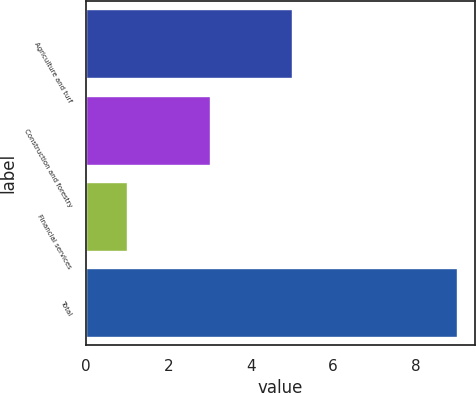<chart> <loc_0><loc_0><loc_500><loc_500><bar_chart><fcel>Agriculture and turf<fcel>Construction and forestry<fcel>Financial services<fcel>Total<nl><fcel>5<fcel>3<fcel>1<fcel>9<nl></chart> 